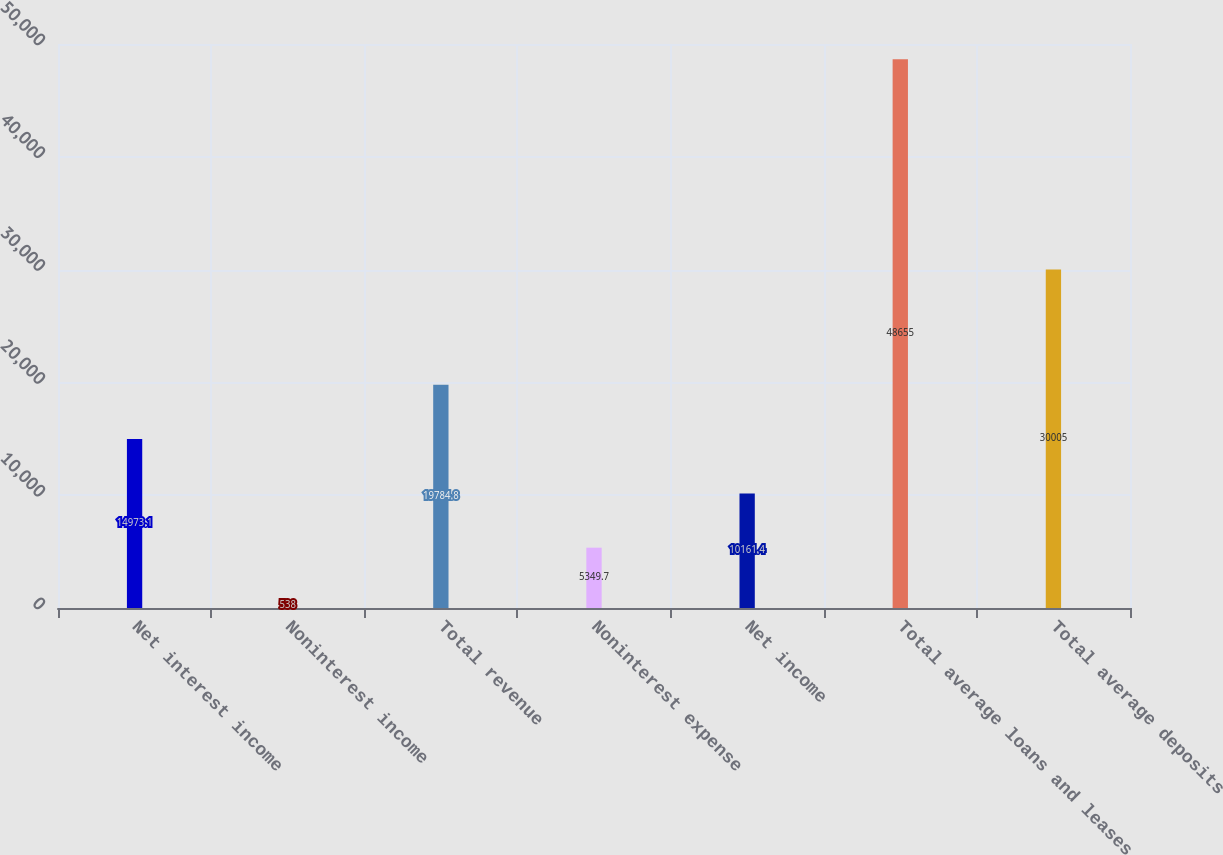<chart> <loc_0><loc_0><loc_500><loc_500><bar_chart><fcel>Net interest income<fcel>Noninterest income<fcel>Total revenue<fcel>Noninterest expense<fcel>Net income<fcel>Total average loans and leases<fcel>Total average deposits<nl><fcel>14973.1<fcel>538<fcel>19784.8<fcel>5349.7<fcel>10161.4<fcel>48655<fcel>30005<nl></chart> 